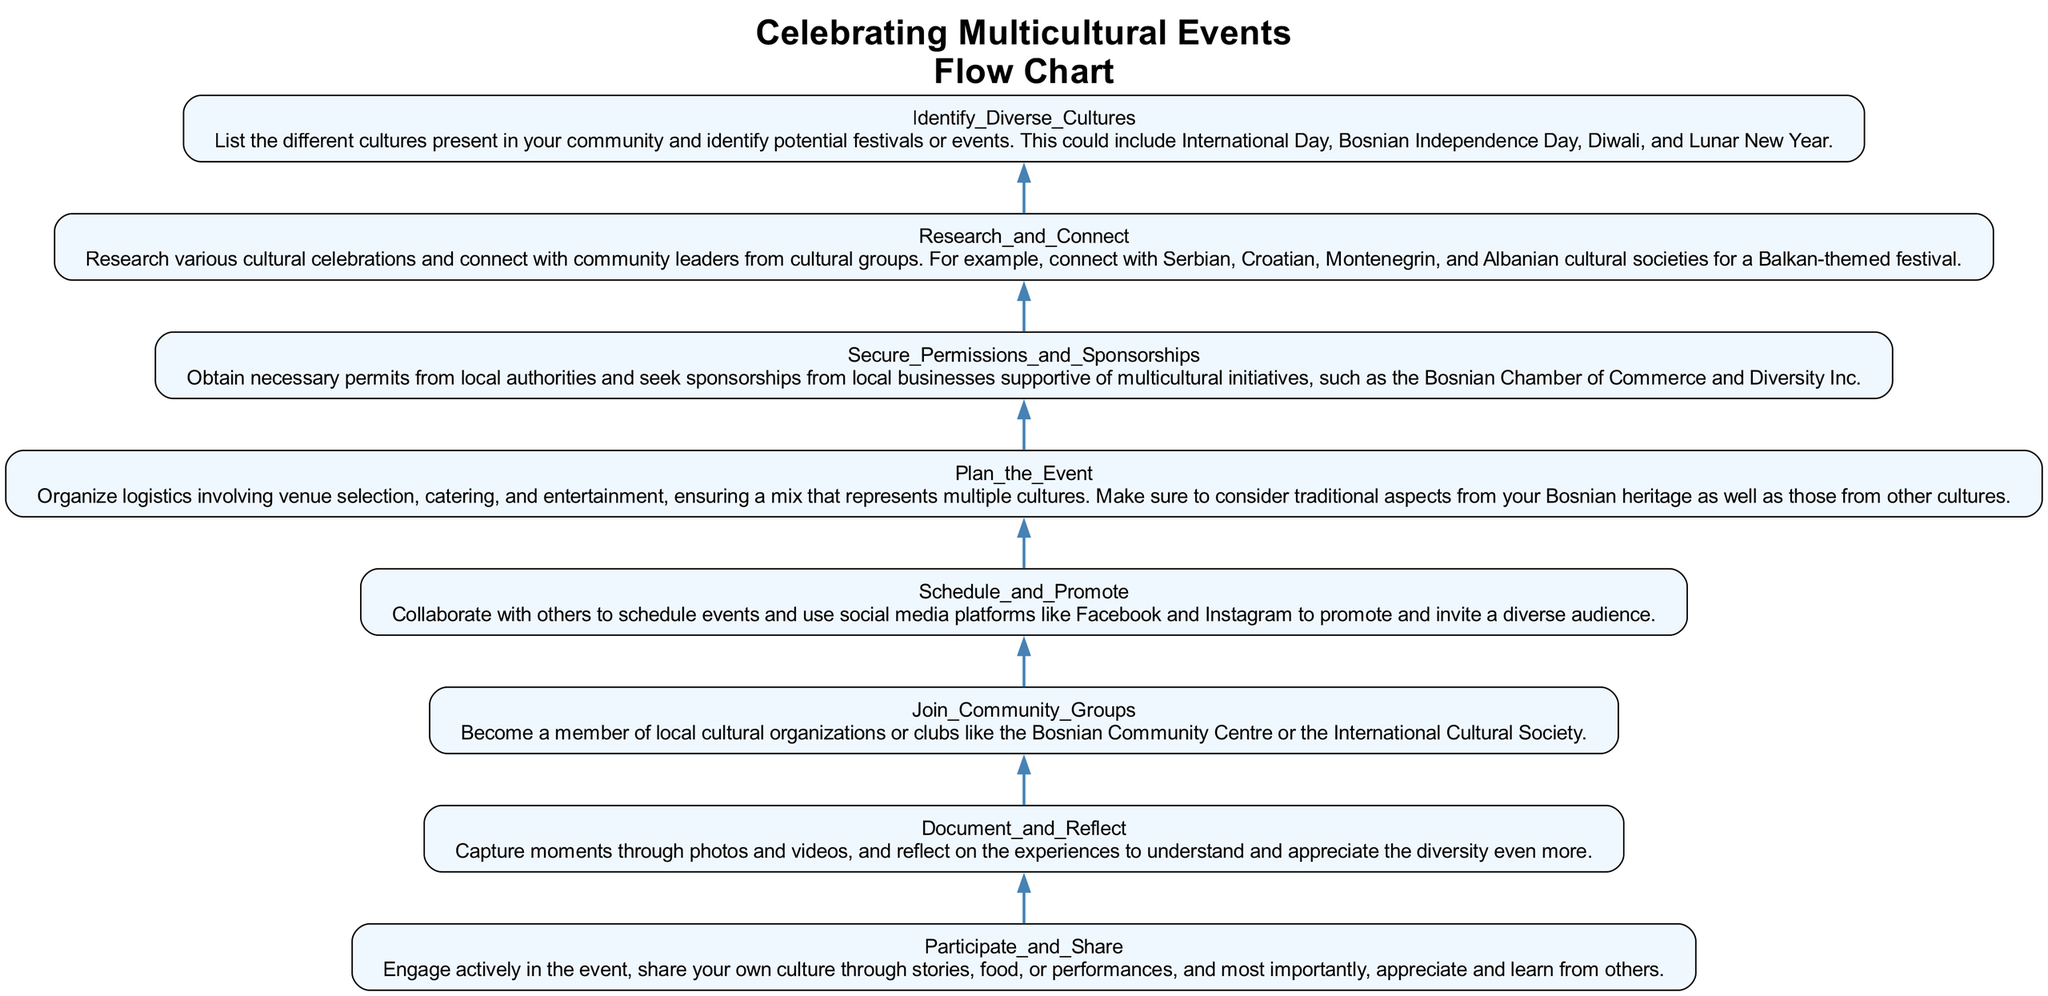What is the first step in the flow chart? The first step in the flow chart is to identify diverse cultures present in the community, which is indicated at the bottom of the diagram.
Answer: Identify Diverse Cultures How many total steps are in the flow chart? By counting the steps provided in the diagram, we find there are eight steps listed from the bottom to the top.
Answer: 8 What is the last step of the flow chart? The last step is to participate and share during the event, which is the topmost node in the flow chart.
Answer: Participate and Share Which step involves capturing moments through photos? The step that mentions capturing moments through photos is "Document and Reflect," which is placed above "Participate and Share."
Answer: Document and Reflect What is required before planning the event? Before planning the event, one must secure permissions and sponsorships, which is outlined as a prerequisite step in the flow chart.
Answer: Secure Permissions and Sponsorships What is the relationship between "Research and Connect" and "Join Community Groups"? "Research and Connect" is a prior step to "Join Community Groups," indicating that understanding various cultures and connecting with leaders is essential before joining organizations.
Answer: "Research and Connect" leads to "Join Community Groups" Which step emphasizes the importance of social media for event promotion? The step that emphasizes the use of social media for promotion is "Schedule and Promote," which appears just above the planning phase.
Answer: Schedule and Promote How does one enhance the appreciation of diversity according to the flow chart? Engaging actively, sharing one's culture, and learning from others are how one enhances the appreciation of diversity, as stated in the final step.
Answer: Participate and Share 